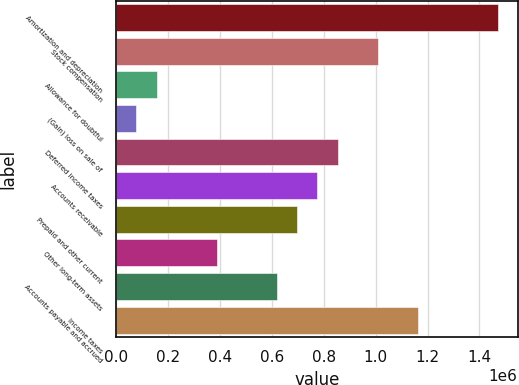<chart> <loc_0><loc_0><loc_500><loc_500><bar_chart><fcel>Amortization and depreciation<fcel>Stock compensation<fcel>Allowance for doubtful<fcel>(Gain) loss on sale of<fcel>Deferred income taxes<fcel>Accounts receivable<fcel>Prepaid and other current<fcel>Other long-term assets<fcel>Accounts payable and accrued<fcel>Income taxes<nl><fcel>1.47321e+06<fcel>1.00801e+06<fcel>155137<fcel>77602.8<fcel>852941<fcel>775407<fcel>697873<fcel>387738<fcel>620339<fcel>1.16308e+06<nl></chart> 